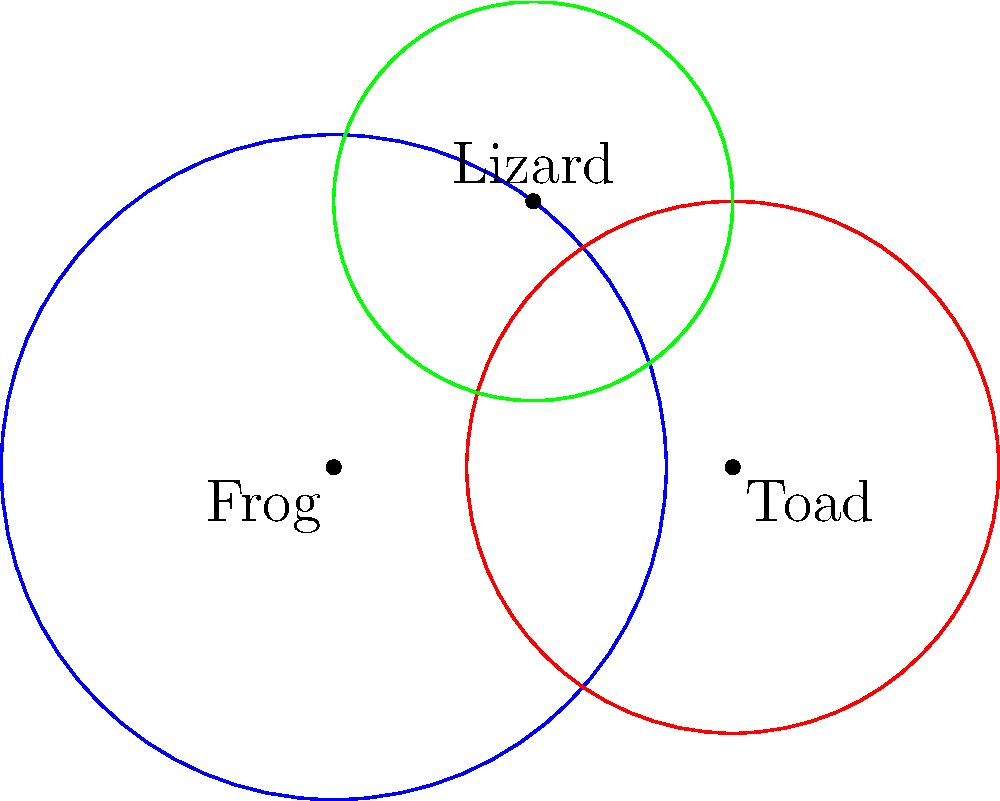In your pest-control system, you have three species with overlapping hunting ranges: frogs, toads, and lizards. Their hunting ranges are represented by circles in the diagram. The frog's range has a radius of 2.5 units, the toad's 2 units, and the lizard's 1.5 units. The centers of these circles form a right-angled triangle. If the area where all three ranges overlap is 0.5 square units, what is the total area covered by at least one of these species? Round your answer to the nearest whole number. Let's approach this step-by-step:

1) First, we need to calculate the areas of each circle:
   Frog: $A_1 = \pi r_1^2 = \pi (2.5)^2 = 6.25\pi$
   Toad: $A_2 = \pi r_2^2 = \pi (2)^2 = 4\pi$
   Lizard: $A_3 = \pi r_3^2 = \pi (1.5)^2 = 2.25\pi$

2) The total area of all circles combined is:
   $A_{total} = 6.25\pi + 4\pi + 2.25\pi = 12.5\pi$

3) However, this includes overlapping areas multiple times. We need to use the principle of inclusion-exclusion:

   $A_{result} = A_1 + A_2 + A_3 - A_{1\cap2} - A_{2\cap3} - A_{1\cap3} + A_{1\cap2\cap3}$

4) We're given that $A_{1\cap2\cap3} = 0.5$

5) To find the other intersection areas, we'd need more information about the relative positions of the circles. However, we can use the given information to our advantage:

6) The area we're looking for is the total area minus the areas that are not covered:
   $A_{result} = A_{total} - (A_1 - A_{covered by 1}) - (A_2 - A_{covered by 2}) - (A_3 - A_{covered by 3})$

7) We know that $A_{covered by 1} + A_{covered by 2} + A_{covered by 3} = A_{result}$

8) Therefore:
   $A_{result} = 12.5\pi - (6.25\pi + 4\pi + 2.25\pi - A_{result})$
   $2A_{result} = 12.5\pi - 12.5\pi + A_{result}$
   $A_{result} = 12.5\pi \approx 39.27$

9) Rounding to the nearest whole number: 39
Answer: 39 square units 